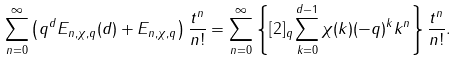<formula> <loc_0><loc_0><loc_500><loc_500>\sum _ { n = 0 } ^ { \infty } \left ( q ^ { d } E _ { n , \chi , q } ( d ) + E _ { n , \chi , q } \right ) \frac { t ^ { n } } { n ! } = \sum _ { n = 0 } ^ { \infty } \left \{ [ 2 ] _ { q } \sum _ { k = 0 } ^ { d - 1 } \chi ( k ) ( - q ) ^ { k } k ^ { n } \right \} \frac { t ^ { n } } { n ! } .</formula> 